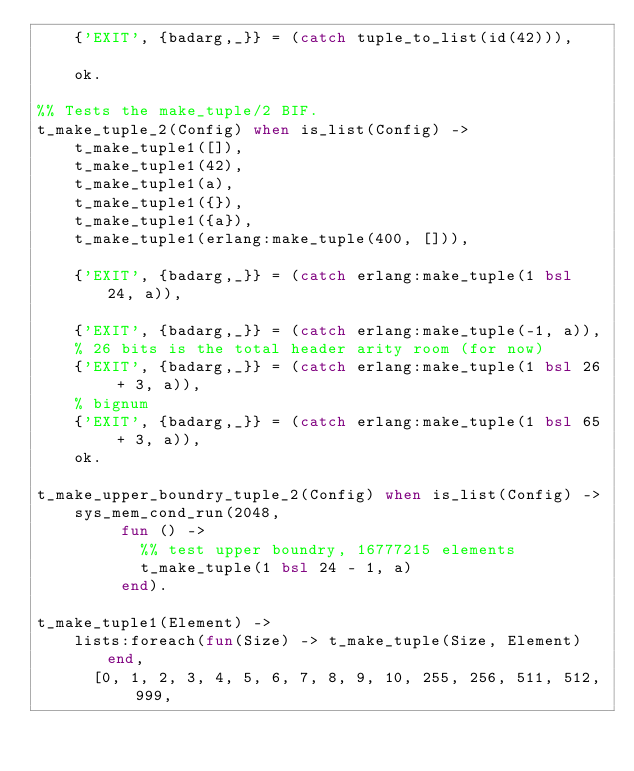<code> <loc_0><loc_0><loc_500><loc_500><_Erlang_>    {'EXIT', {badarg,_}} = (catch tuple_to_list(id(42))),

    ok.

%% Tests the make_tuple/2 BIF.
t_make_tuple_2(Config) when is_list(Config) ->
    t_make_tuple1([]),
    t_make_tuple1(42),
    t_make_tuple1(a),
    t_make_tuple1({}),
    t_make_tuple1({a}),
    t_make_tuple1(erlang:make_tuple(400, [])),

    {'EXIT', {badarg,_}} = (catch erlang:make_tuple(1 bsl 24, a)),

    {'EXIT', {badarg,_}} = (catch erlang:make_tuple(-1, a)),
    % 26 bits is the total header arity room (for now)
    {'EXIT', {badarg,_}} = (catch erlang:make_tuple(1 bsl 26 + 3, a)),
    % bignum
    {'EXIT', {badarg,_}} = (catch erlang:make_tuple(1 bsl 65 + 3, a)),
    ok.

t_make_upper_boundry_tuple_2(Config) when is_list(Config) ->
    sys_mem_cond_run(2048,
		     fun () ->
			     %% test upper boundry, 16777215 elements
			     t_make_tuple(1 bsl 24 - 1, a)
		     end).

t_make_tuple1(Element) ->
    lists:foreach(fun(Size) -> t_make_tuple(Size, Element) end,
		  [0, 1, 2, 3, 4, 5, 6, 7, 8, 9, 10, 255, 256, 511, 512, 999,</code> 